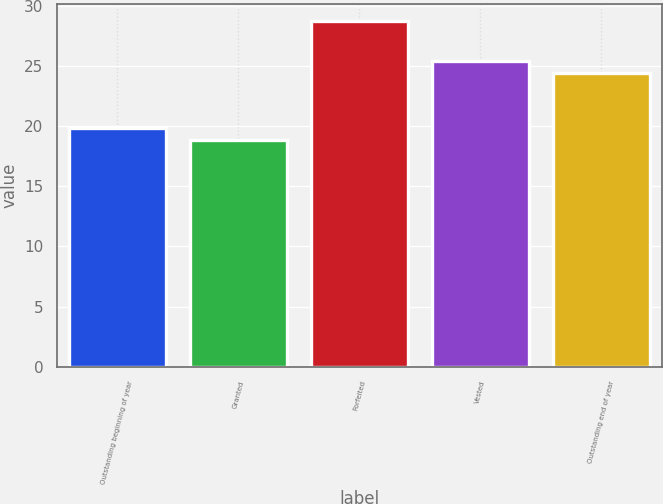<chart> <loc_0><loc_0><loc_500><loc_500><bar_chart><fcel>Outstanding beginning of year<fcel>Granted<fcel>Forfeited<fcel>Vested<fcel>Outstanding end of year<nl><fcel>19.83<fcel>18.84<fcel>28.71<fcel>25.4<fcel>24.41<nl></chart> 